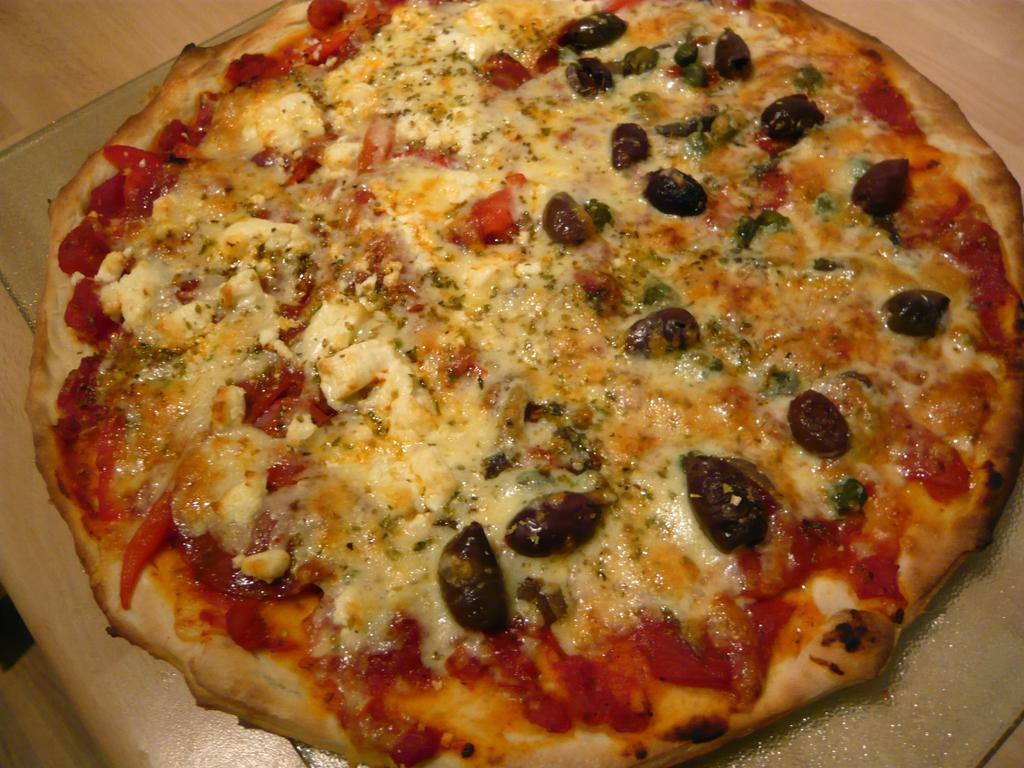What type of food is the main subject of the image? There is a pizza in the image. What is the pizza resting on? The pizza is on an object. What can be seen on top of the pizza? There are ingredients on the pizza. Who is the creator of the pizza system in the image? A: There is no pizza system present in the image, and therefore no creator can be identified. Can you tell me how many grapes are on the pizza? There is no information about grapes on the pizza, so it cannot be determined from the image. 